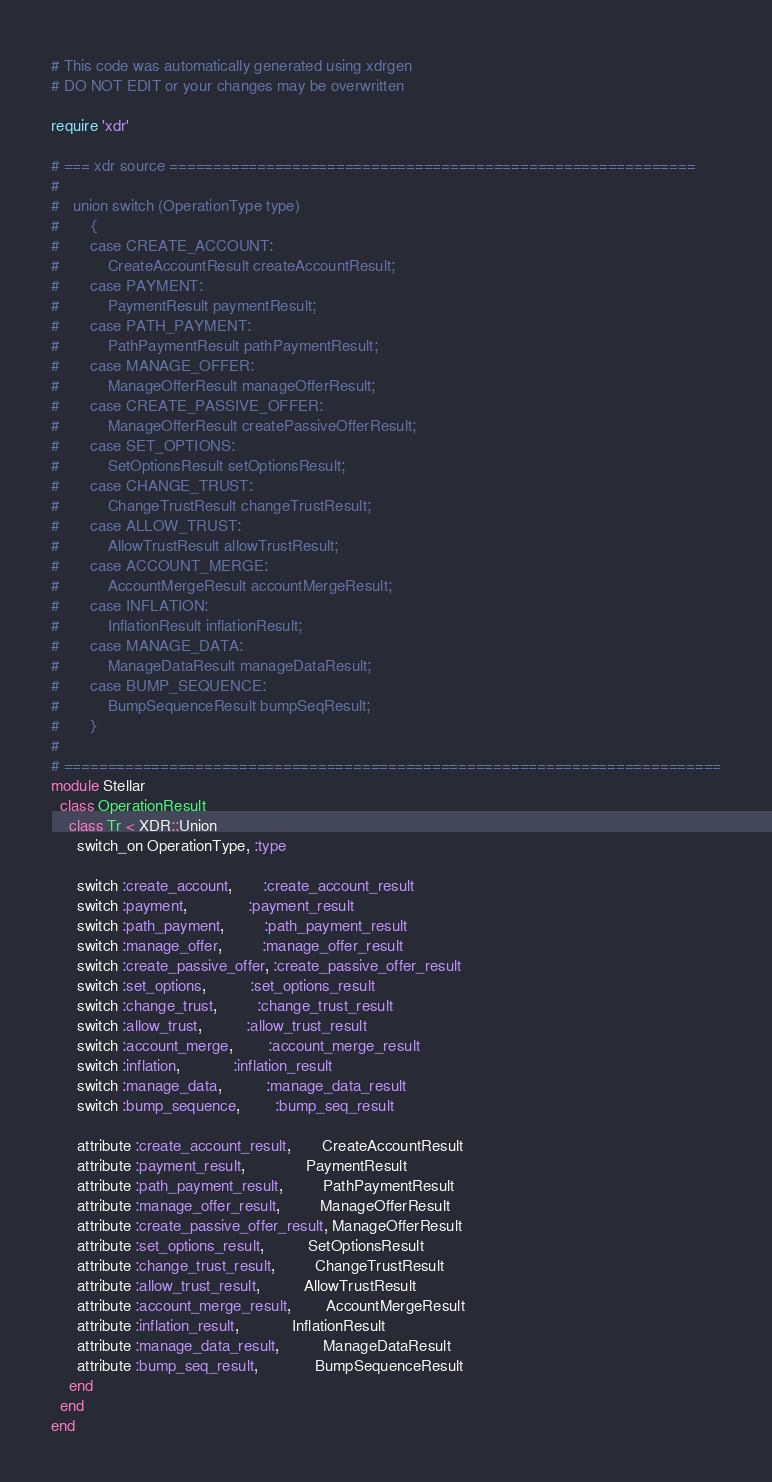Convert code to text. <code><loc_0><loc_0><loc_500><loc_500><_Ruby_># This code was automatically generated using xdrgen
# DO NOT EDIT or your changes may be overwritten

require 'xdr'

# === xdr source ============================================================
#
#   union switch (OperationType type)
#       {
#       case CREATE_ACCOUNT:
#           CreateAccountResult createAccountResult;
#       case PAYMENT:
#           PaymentResult paymentResult;
#       case PATH_PAYMENT:
#           PathPaymentResult pathPaymentResult;
#       case MANAGE_OFFER:
#           ManageOfferResult manageOfferResult;
#       case CREATE_PASSIVE_OFFER:
#           ManageOfferResult createPassiveOfferResult;
#       case SET_OPTIONS:
#           SetOptionsResult setOptionsResult;
#       case CHANGE_TRUST:
#           ChangeTrustResult changeTrustResult;
#       case ALLOW_TRUST:
#           AllowTrustResult allowTrustResult;
#       case ACCOUNT_MERGE:
#           AccountMergeResult accountMergeResult;
#       case INFLATION:
#           InflationResult inflationResult;
#       case MANAGE_DATA:
#           ManageDataResult manageDataResult;
#       case BUMP_SEQUENCE:
#           BumpSequenceResult bumpSeqResult;
#       }
#
# ===========================================================================
module Stellar
  class OperationResult
    class Tr < XDR::Union
      switch_on OperationType, :type

      switch :create_account,       :create_account_result
      switch :payment,              :payment_result
      switch :path_payment,         :path_payment_result
      switch :manage_offer,         :manage_offer_result
      switch :create_passive_offer, :create_passive_offer_result
      switch :set_options,          :set_options_result
      switch :change_trust,         :change_trust_result
      switch :allow_trust,          :allow_trust_result
      switch :account_merge,        :account_merge_result
      switch :inflation,            :inflation_result
      switch :manage_data,          :manage_data_result
      switch :bump_sequence,        :bump_seq_result

      attribute :create_account_result,       CreateAccountResult
      attribute :payment_result,              PaymentResult
      attribute :path_payment_result,         PathPaymentResult
      attribute :manage_offer_result,         ManageOfferResult
      attribute :create_passive_offer_result, ManageOfferResult
      attribute :set_options_result,          SetOptionsResult
      attribute :change_trust_result,         ChangeTrustResult
      attribute :allow_trust_result,          AllowTrustResult
      attribute :account_merge_result,        AccountMergeResult
      attribute :inflation_result,            InflationResult
      attribute :manage_data_result,          ManageDataResult
      attribute :bump_seq_result,             BumpSequenceResult
    end
  end
end
</code> 